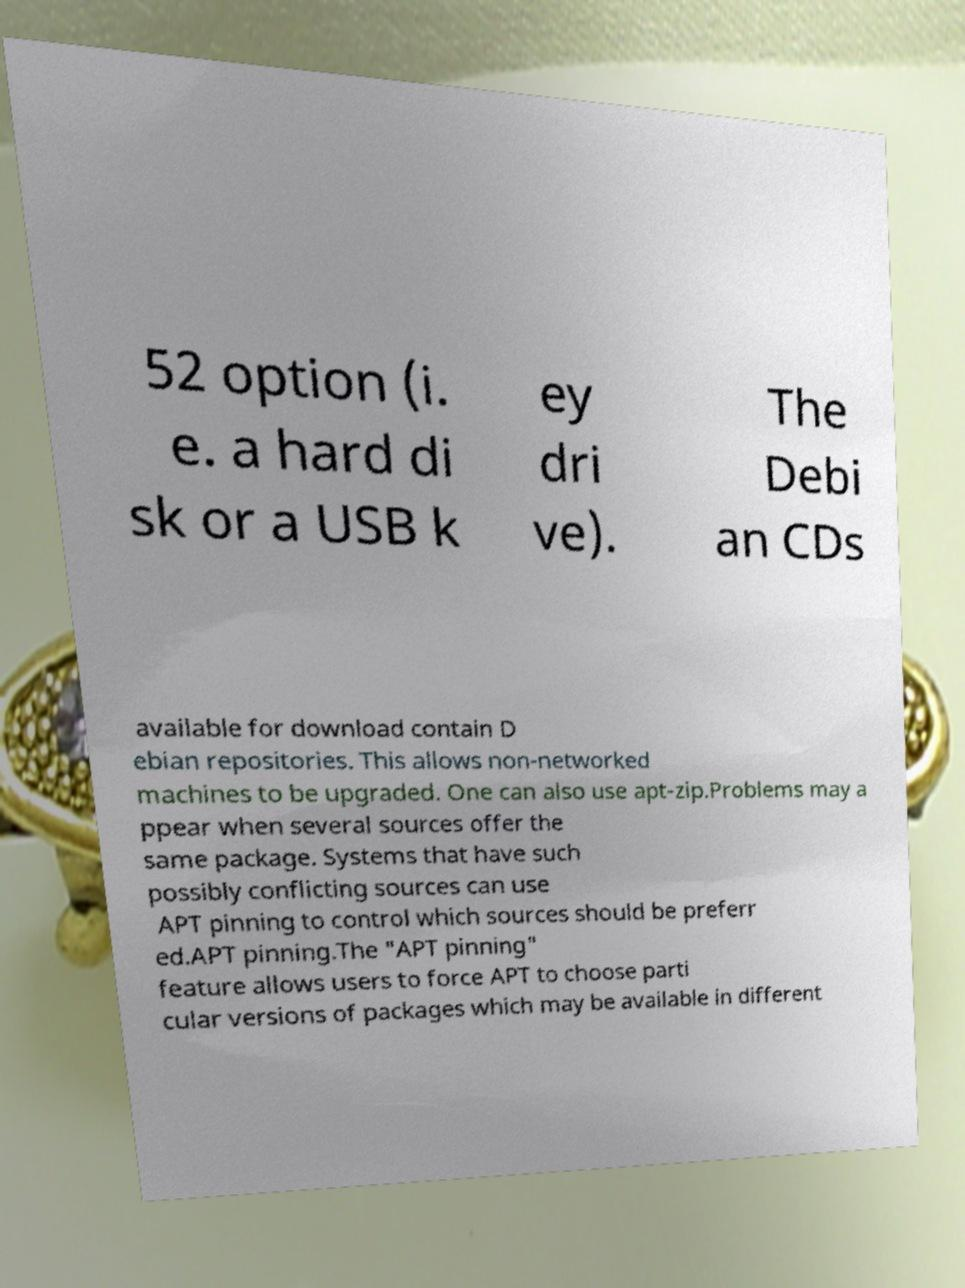Could you extract and type out the text from this image? 52 option (i. e. a hard di sk or a USB k ey dri ve). The Debi an CDs available for download contain D ebian repositories. This allows non-networked machines to be upgraded. One can also use apt-zip.Problems may a ppear when several sources offer the same package. Systems that have such possibly conflicting sources can use APT pinning to control which sources should be preferr ed.APT pinning.The "APT pinning" feature allows users to force APT to choose parti cular versions of packages which may be available in different 